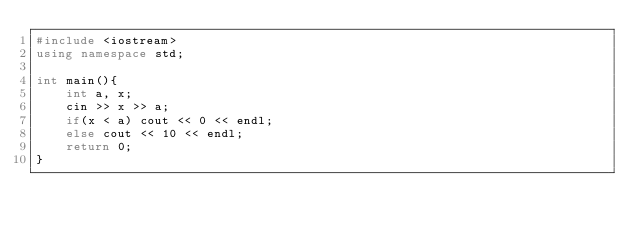Convert code to text. <code><loc_0><loc_0><loc_500><loc_500><_C++_>#include <iostream>
using namespace std;

int main(){
    int a, x;
    cin >> x >> a;
    if(x < a) cout << 0 << endl;
    else cout << 10 << endl;
    return 0;
}</code> 